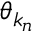<formula> <loc_0><loc_0><loc_500><loc_500>\theta _ { k _ { n } }</formula> 